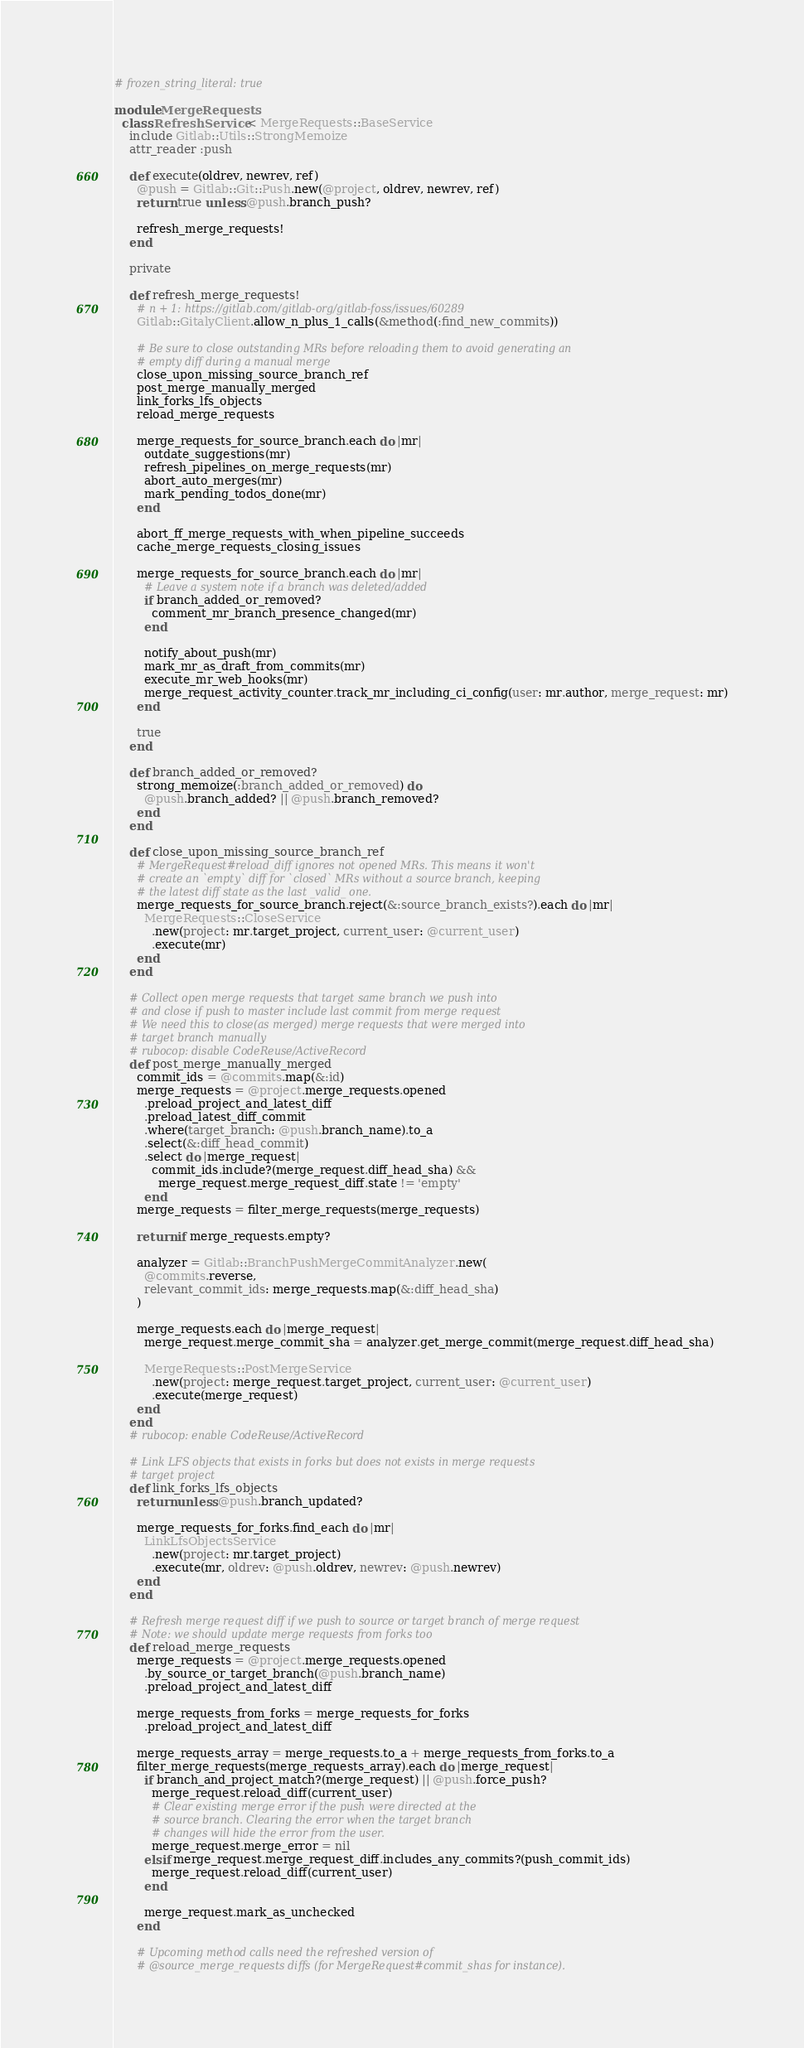<code> <loc_0><loc_0><loc_500><loc_500><_Ruby_># frozen_string_literal: true

module MergeRequests
  class RefreshService < MergeRequests::BaseService
    include Gitlab::Utils::StrongMemoize
    attr_reader :push

    def execute(oldrev, newrev, ref)
      @push = Gitlab::Git::Push.new(@project, oldrev, newrev, ref)
      return true unless @push.branch_push?

      refresh_merge_requests!
    end

    private

    def refresh_merge_requests!
      # n + 1: https://gitlab.com/gitlab-org/gitlab-foss/issues/60289
      Gitlab::GitalyClient.allow_n_plus_1_calls(&method(:find_new_commits))

      # Be sure to close outstanding MRs before reloading them to avoid generating an
      # empty diff during a manual merge
      close_upon_missing_source_branch_ref
      post_merge_manually_merged
      link_forks_lfs_objects
      reload_merge_requests

      merge_requests_for_source_branch.each do |mr|
        outdate_suggestions(mr)
        refresh_pipelines_on_merge_requests(mr)
        abort_auto_merges(mr)
        mark_pending_todos_done(mr)
      end

      abort_ff_merge_requests_with_when_pipeline_succeeds
      cache_merge_requests_closing_issues

      merge_requests_for_source_branch.each do |mr|
        # Leave a system note if a branch was deleted/added
        if branch_added_or_removed?
          comment_mr_branch_presence_changed(mr)
        end

        notify_about_push(mr)
        mark_mr_as_draft_from_commits(mr)
        execute_mr_web_hooks(mr)
        merge_request_activity_counter.track_mr_including_ci_config(user: mr.author, merge_request: mr)
      end

      true
    end

    def branch_added_or_removed?
      strong_memoize(:branch_added_or_removed) do
        @push.branch_added? || @push.branch_removed?
      end
    end

    def close_upon_missing_source_branch_ref
      # MergeRequest#reload_diff ignores not opened MRs. This means it won't
      # create an `empty` diff for `closed` MRs without a source branch, keeping
      # the latest diff state as the last _valid_ one.
      merge_requests_for_source_branch.reject(&:source_branch_exists?).each do |mr|
        MergeRequests::CloseService
          .new(project: mr.target_project, current_user: @current_user)
          .execute(mr)
      end
    end

    # Collect open merge requests that target same branch we push into
    # and close if push to master include last commit from merge request
    # We need this to close(as merged) merge requests that were merged into
    # target branch manually
    # rubocop: disable CodeReuse/ActiveRecord
    def post_merge_manually_merged
      commit_ids = @commits.map(&:id)
      merge_requests = @project.merge_requests.opened
        .preload_project_and_latest_diff
        .preload_latest_diff_commit
        .where(target_branch: @push.branch_name).to_a
        .select(&:diff_head_commit)
        .select do |merge_request|
          commit_ids.include?(merge_request.diff_head_sha) &&
            merge_request.merge_request_diff.state != 'empty'
        end
      merge_requests = filter_merge_requests(merge_requests)

      return if merge_requests.empty?

      analyzer = Gitlab::BranchPushMergeCommitAnalyzer.new(
        @commits.reverse,
        relevant_commit_ids: merge_requests.map(&:diff_head_sha)
      )

      merge_requests.each do |merge_request|
        merge_request.merge_commit_sha = analyzer.get_merge_commit(merge_request.diff_head_sha)

        MergeRequests::PostMergeService
          .new(project: merge_request.target_project, current_user: @current_user)
          .execute(merge_request)
      end
    end
    # rubocop: enable CodeReuse/ActiveRecord

    # Link LFS objects that exists in forks but does not exists in merge requests
    # target project
    def link_forks_lfs_objects
      return unless @push.branch_updated?

      merge_requests_for_forks.find_each do |mr|
        LinkLfsObjectsService
          .new(project: mr.target_project)
          .execute(mr, oldrev: @push.oldrev, newrev: @push.newrev)
      end
    end

    # Refresh merge request diff if we push to source or target branch of merge request
    # Note: we should update merge requests from forks too
    def reload_merge_requests
      merge_requests = @project.merge_requests.opened
        .by_source_or_target_branch(@push.branch_name)
        .preload_project_and_latest_diff

      merge_requests_from_forks = merge_requests_for_forks
        .preload_project_and_latest_diff

      merge_requests_array = merge_requests.to_a + merge_requests_from_forks.to_a
      filter_merge_requests(merge_requests_array).each do |merge_request|
        if branch_and_project_match?(merge_request) || @push.force_push?
          merge_request.reload_diff(current_user)
          # Clear existing merge error if the push were directed at the
          # source branch. Clearing the error when the target branch
          # changes will hide the error from the user.
          merge_request.merge_error = nil
        elsif merge_request.merge_request_diff.includes_any_commits?(push_commit_ids)
          merge_request.reload_diff(current_user)
        end

        merge_request.mark_as_unchecked
      end

      # Upcoming method calls need the refreshed version of
      # @source_merge_requests diffs (for MergeRequest#commit_shas for instance).</code> 